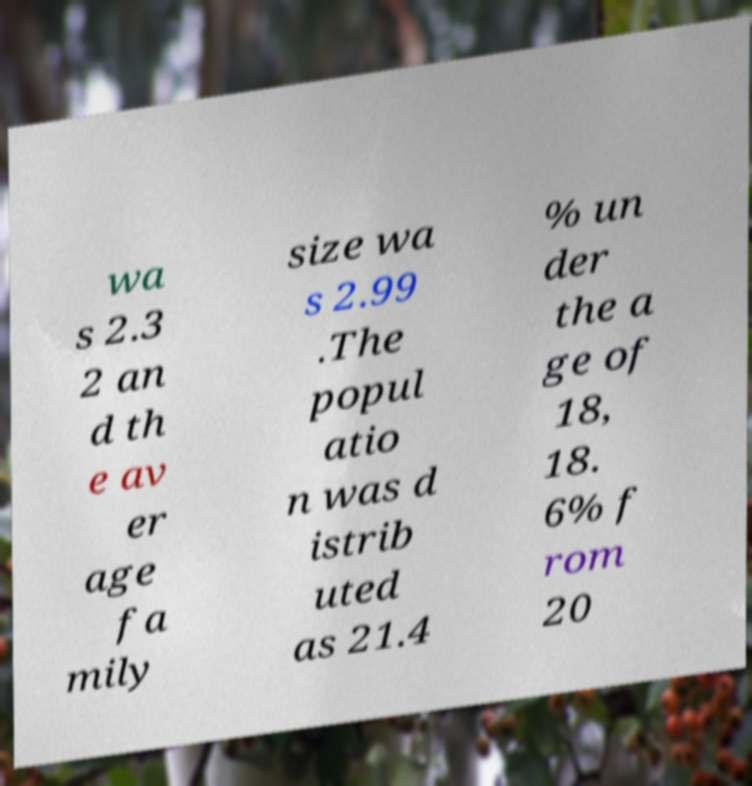There's text embedded in this image that I need extracted. Can you transcribe it verbatim? wa s 2.3 2 an d th e av er age fa mily size wa s 2.99 .The popul atio n was d istrib uted as 21.4 % un der the a ge of 18, 18. 6% f rom 20 